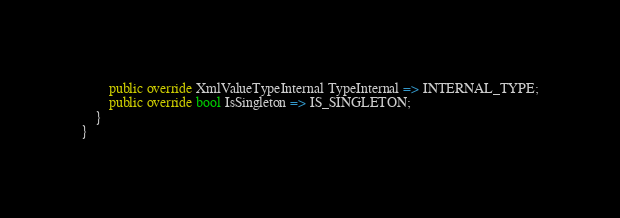Convert code to text. <code><loc_0><loc_0><loc_500><loc_500><_C#_>        public override XmlValueTypeInternal TypeInternal => INTERNAL_TYPE;
        public override bool IsSingleton => IS_SINGLETON;
    }
}</code> 